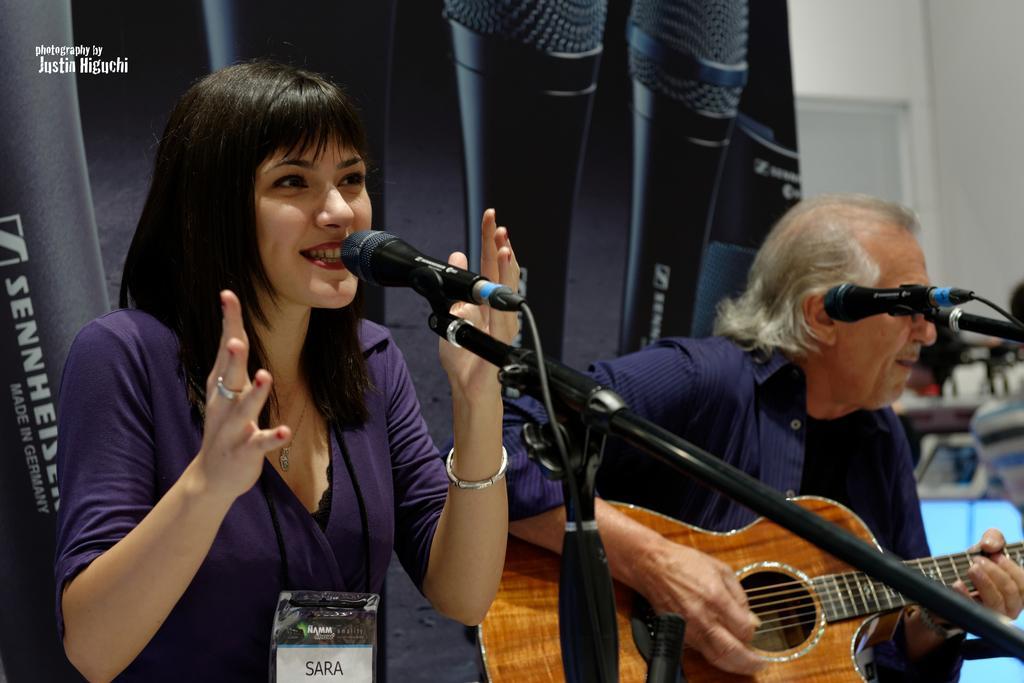Could you give a brief overview of what you see in this image? In this image I see woman who is smiling and she is in front of a mic, I can also see that there is a man who is holding a guitar. 